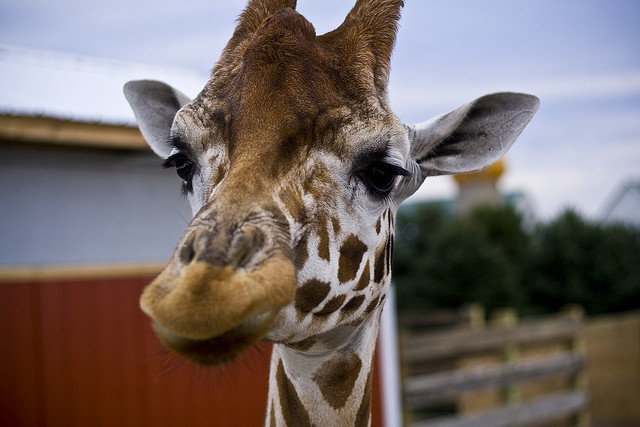Describe the objects in this image and their specific colors. I can see a giraffe in darkgray, black, maroon, and gray tones in this image. 